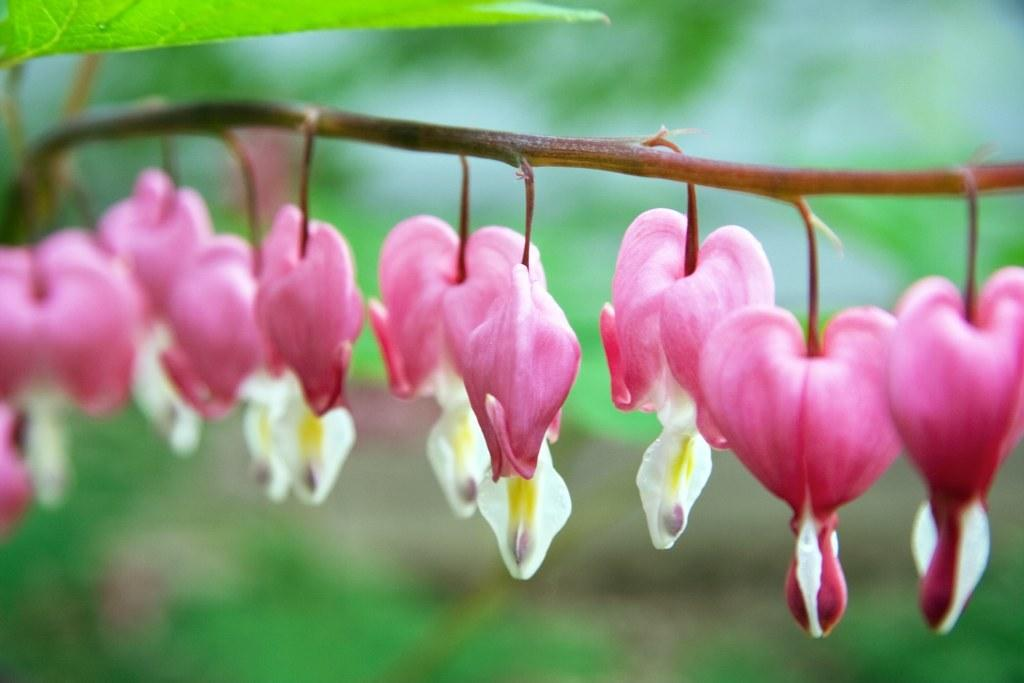What type of plant is present in the image? The image contains a plant with flowers. Can you describe the plant's appearance? The plant has flowers and leaves visible at the top. What type of reaction does the wren have to the fan in the image? There is no wren or fan present in the image, so it is not possible to determine any reaction. 